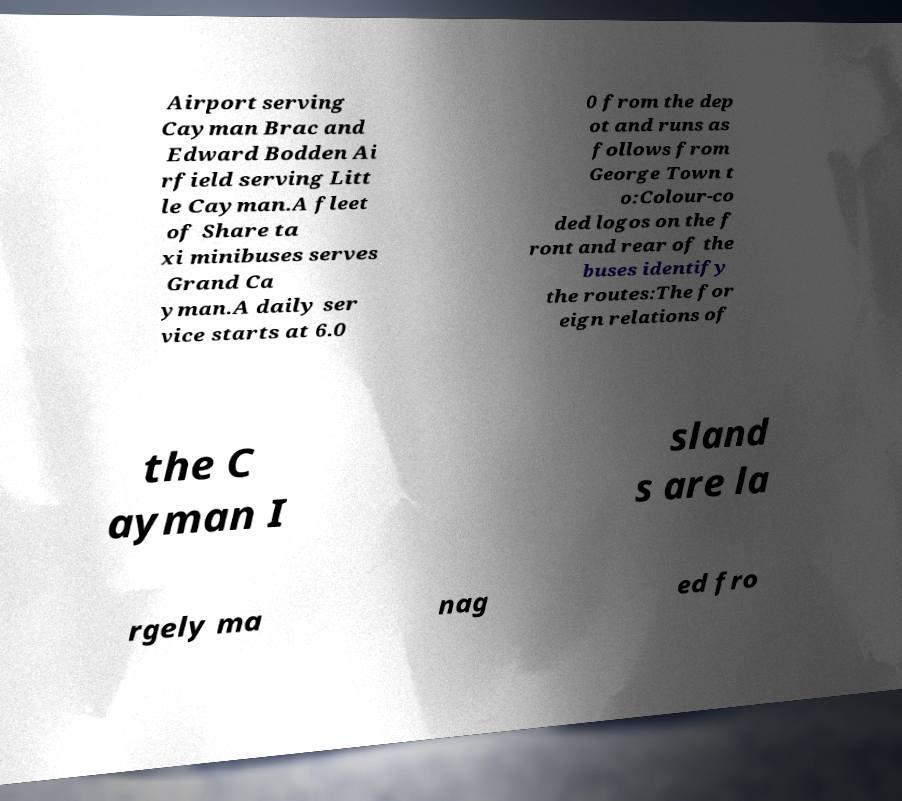Could you extract and type out the text from this image? Airport serving Cayman Brac and Edward Bodden Ai rfield serving Litt le Cayman.A fleet of Share ta xi minibuses serves Grand Ca yman.A daily ser vice starts at 6.0 0 from the dep ot and runs as follows from George Town t o:Colour-co ded logos on the f ront and rear of the buses identify the routes:The for eign relations of the C ayman I sland s are la rgely ma nag ed fro 